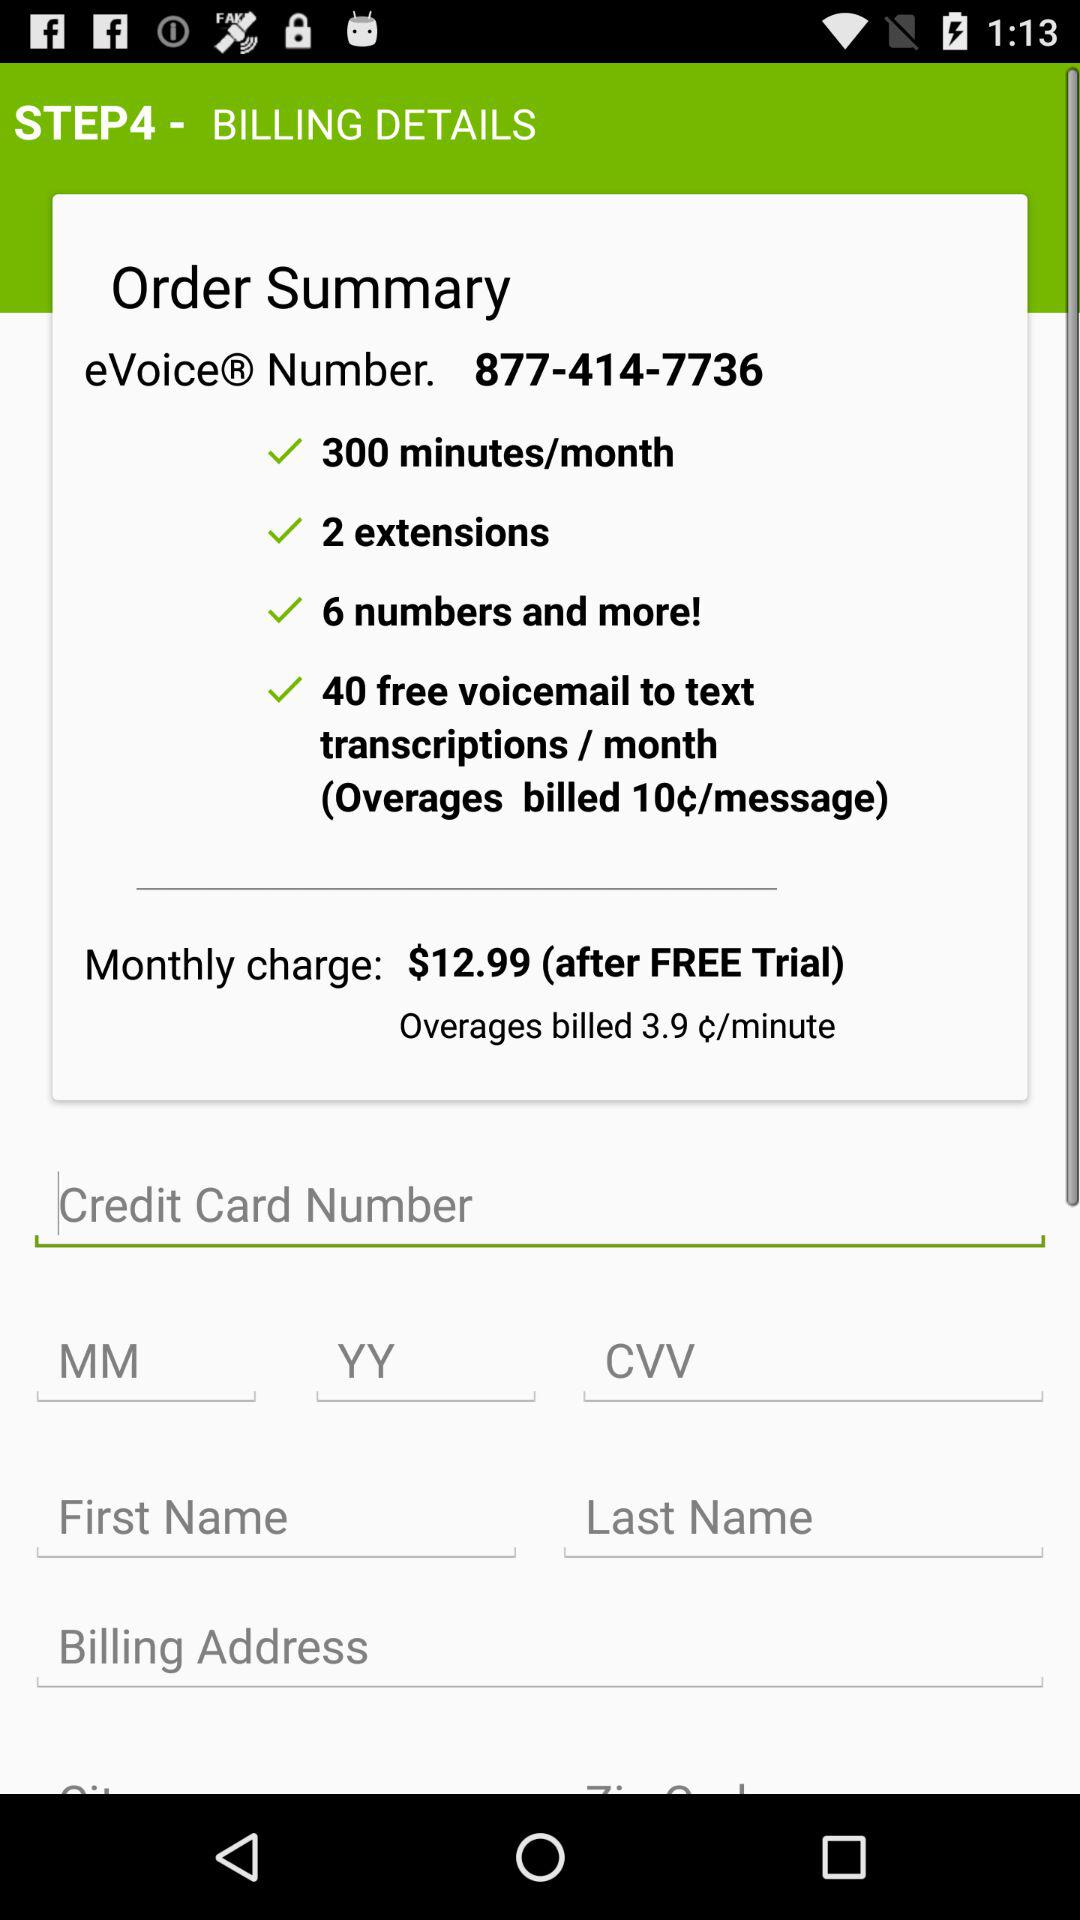How many minutes per month are available? There are 300 minutes per month available. 